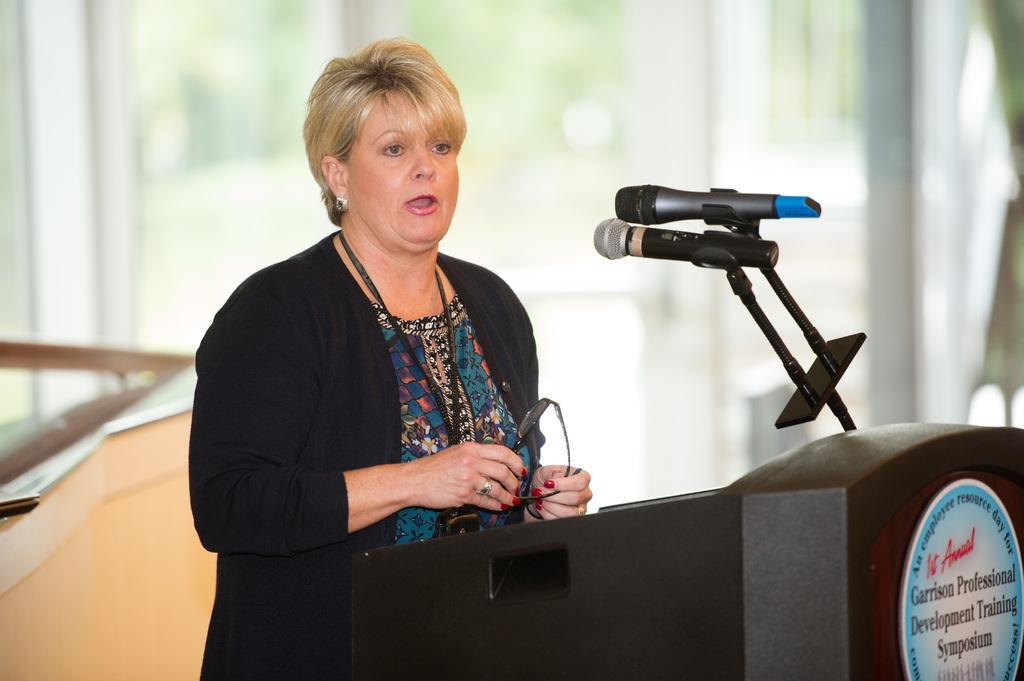Who is the main subject in the image? There is a woman in the image. What is the woman doing in the image? The woman is standing in front of a podium. What objects are visible near the woman? There are microphones in the image. Can you describe the background of the image? The background of the image is blurred. What type of wrench is the woman using in the image? There is no wrench present in the image. How many snakes can be seen slithering around the podium in the image? There are no snakes present in the image. 